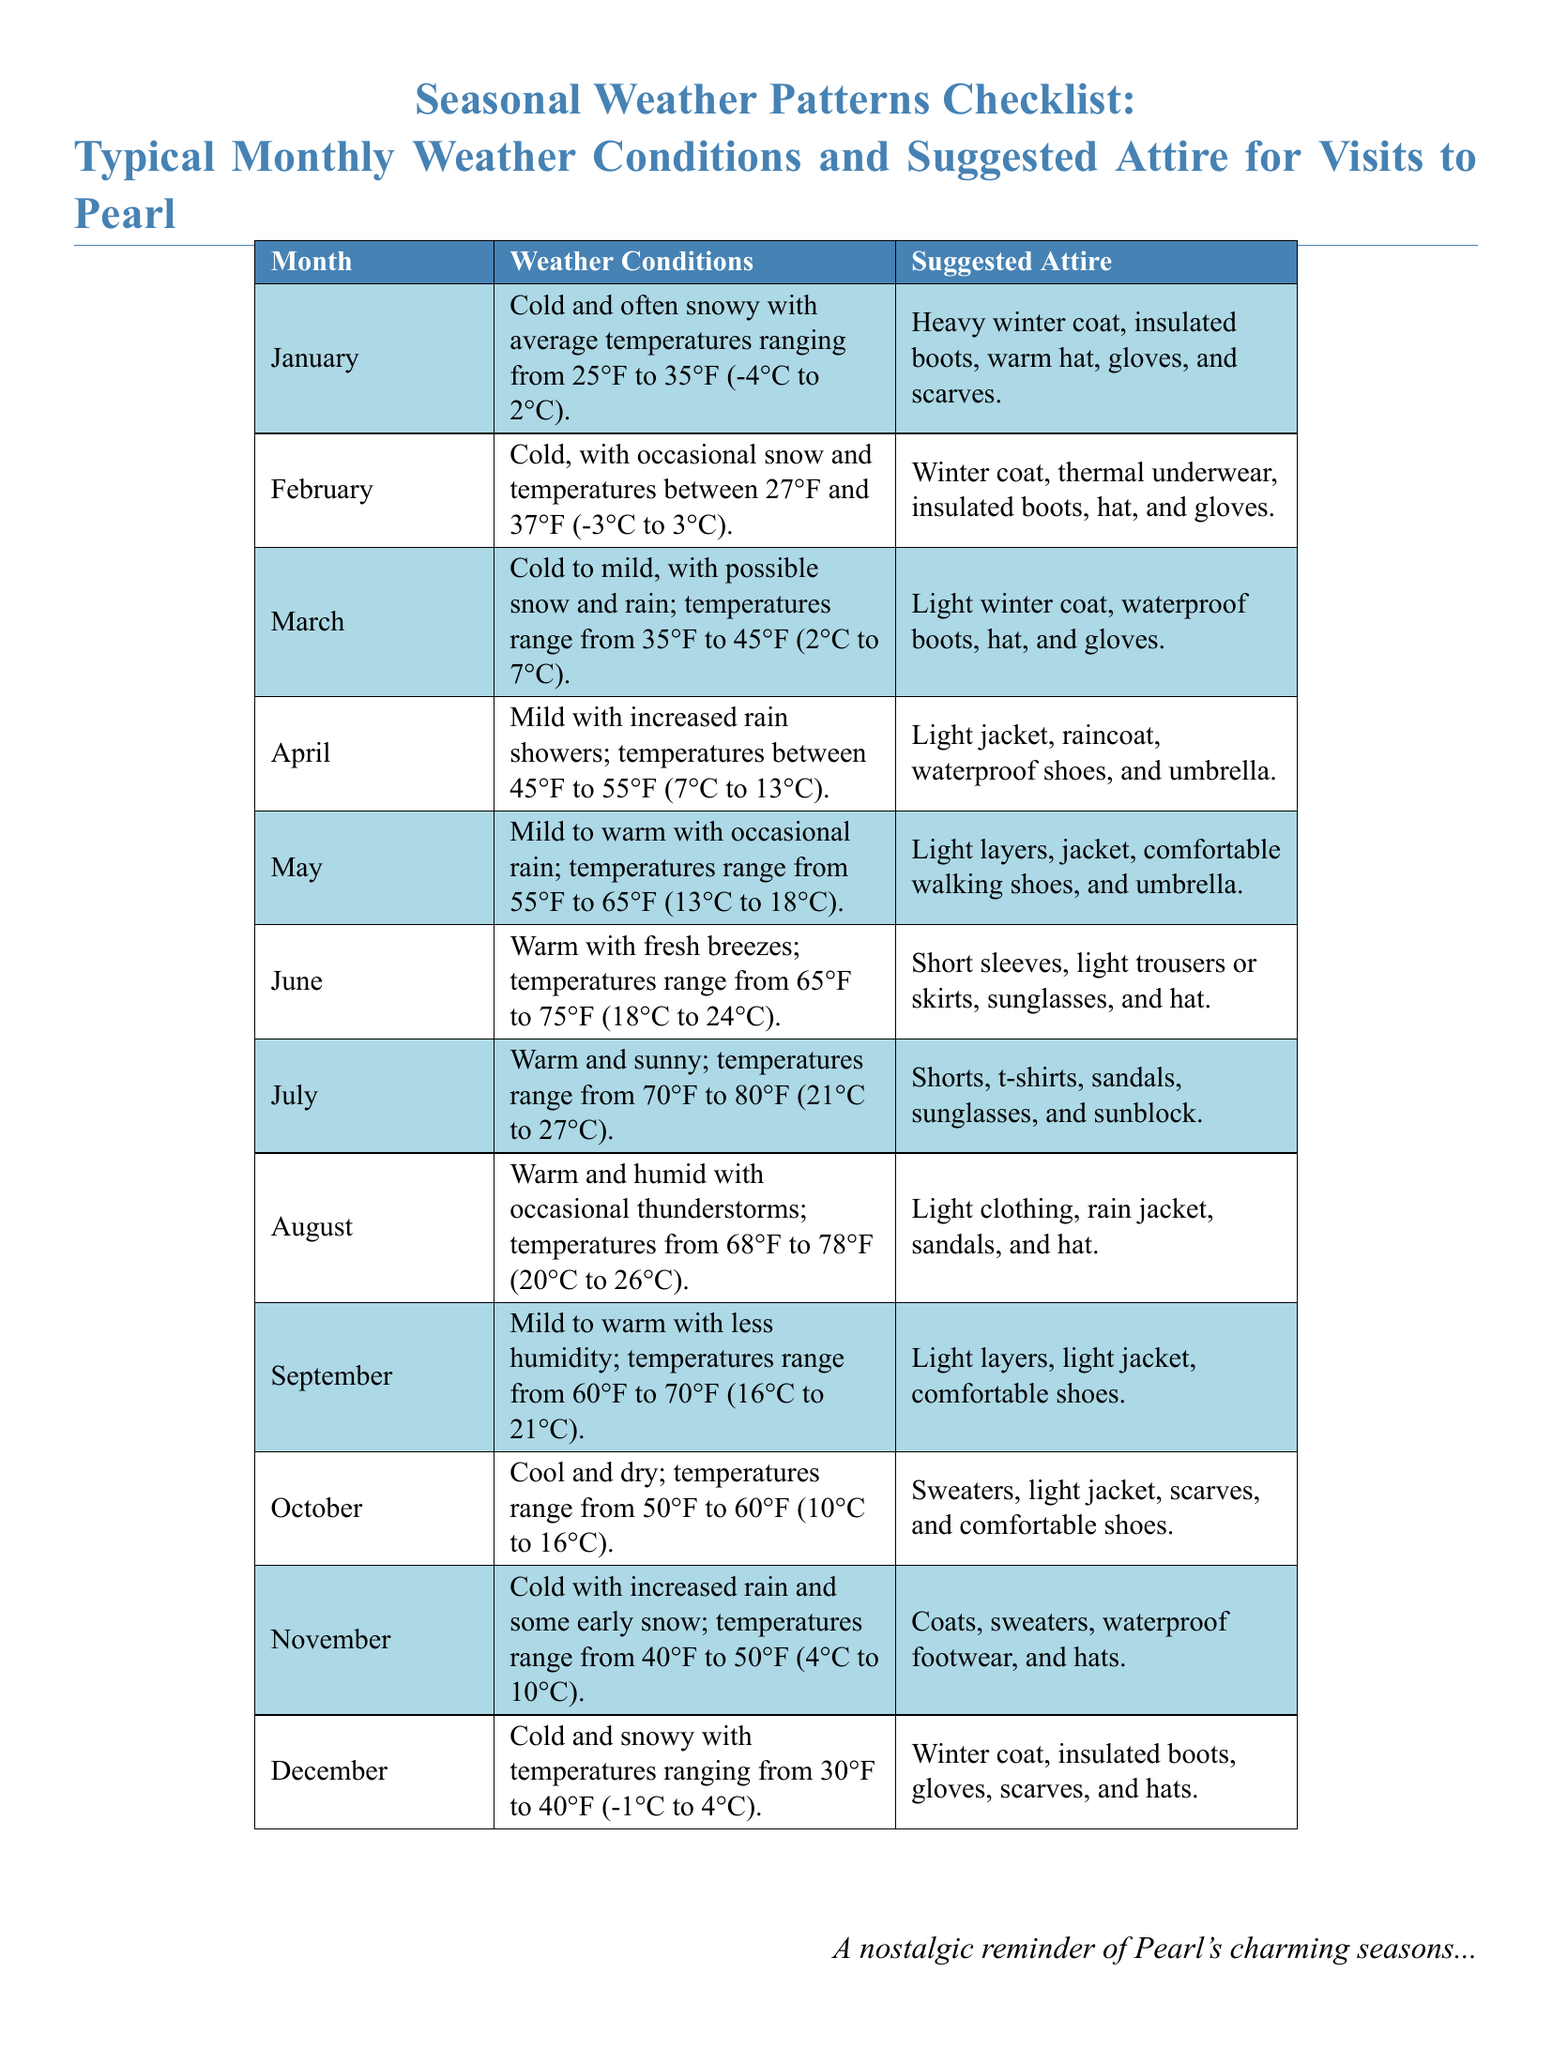What is the average temperature in January? The average temperature in January is given as ranging from 25°F to 35°F.
Answer: 25°F to 35°F What type of coat is suggested for December? The suggested attire for December includes a winter coat.
Answer: Winter coat Which month has temperatures between 45°F and 55°F? The temperature range of 45°F to 55°F is specified for April.
Answer: April What is the suggested attire for July? The suggested attire for July includes shorts, t-shirts, and sunglasses.
Answer: Shorts, t-shirts, sandals, sunglasses In which month might you need an umbrella? April mentions increased rain showers which suggest needing an umbrella.
Answer: April Which month experiences the least humidity? September is noted to be mild to warm with less humidity.
Answer: September For what temperatures is a rain jacket suggested? A rain jacket is suggested during August when temperatures range from 68°F to 78°F.
Answer: August What is the weather condition for February? February is described as cold with occasional snow.
Answer: Cold with occasional snow What type of shoes is recommended for April? Waterproof shoes are recommended for April during increased rain showers.
Answer: Waterproof shoes 